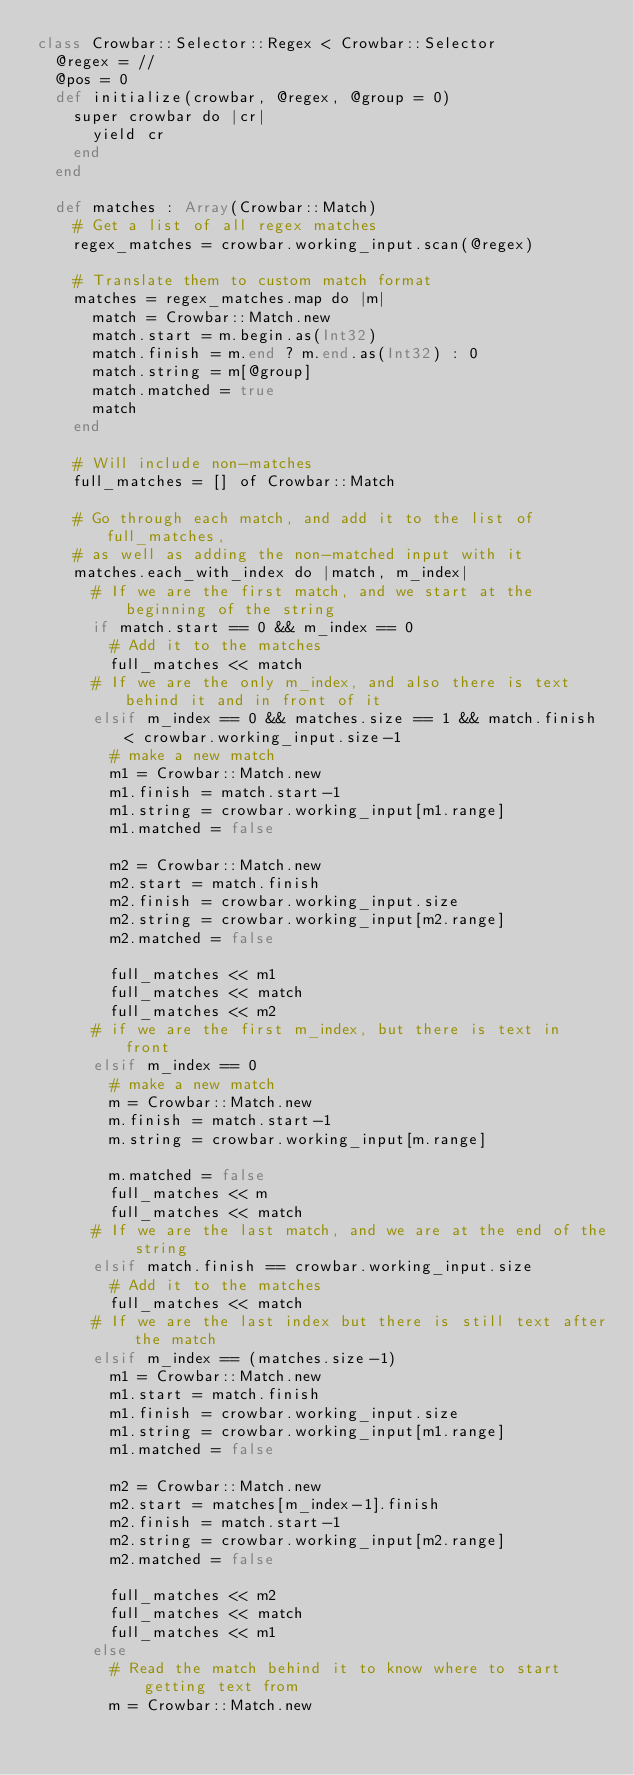<code> <loc_0><loc_0><loc_500><loc_500><_Crystal_>class Crowbar::Selector::Regex < Crowbar::Selector
  @regex = //
  @pos = 0
  def initialize(crowbar, @regex, @group = 0)
    super crowbar do |cr|
      yield cr
    end
  end

  def matches : Array(Crowbar::Match)
    # Get a list of all regex matches
    regex_matches = crowbar.working_input.scan(@regex)

    # Translate them to custom match format
    matches = regex_matches.map do |m|
      match = Crowbar::Match.new
      match.start = m.begin.as(Int32)
      match.finish = m.end ? m.end.as(Int32) : 0
      match.string = m[@group]
      match.matched = true
      match
    end

    # Will include non-matches
    full_matches = [] of Crowbar::Match

    # Go through each match, and add it to the list of full_matches,
    # as well as adding the non-matched input with it
    matches.each_with_index do |match, m_index|
      # If we are the first match, and we start at the beginning of the string
      if match.start == 0 && m_index == 0
        # Add it to the matches
        full_matches << match
      # If we are the only m_index, and also there is text behind it and in front of it
      elsif m_index == 0 && matches.size == 1 && match.finish < crowbar.working_input.size-1
        # make a new match
        m1 = Crowbar::Match.new
        m1.finish = match.start-1
        m1.string = crowbar.working_input[m1.range]
        m1.matched = false

        m2 = Crowbar::Match.new
        m2.start = match.finish
        m2.finish = crowbar.working_input.size
        m2.string = crowbar.working_input[m2.range]
        m2.matched = false

        full_matches << m1
        full_matches << match
        full_matches << m2
      # if we are the first m_index, but there is text in front
      elsif m_index == 0
        # make a new match
        m = Crowbar::Match.new
        m.finish = match.start-1
        m.string = crowbar.working_input[m.range]

        m.matched = false
        full_matches << m
        full_matches << match
      # If we are the last match, and we are at the end of the string
      elsif match.finish == crowbar.working_input.size
        # Add it to the matches
        full_matches << match
      # If we are the last index but there is still text after the match
      elsif m_index == (matches.size-1)
        m1 = Crowbar::Match.new
        m1.start = match.finish
        m1.finish = crowbar.working_input.size
        m1.string = crowbar.working_input[m1.range]
        m1.matched = false

        m2 = Crowbar::Match.new
        m2.start = matches[m_index-1].finish
        m2.finish = match.start-1
        m2.string = crowbar.working_input[m2.range]
        m2.matched = false

        full_matches << m2
        full_matches << match
        full_matches << m1
      else
        # Read the match behind it to know where to start getting text from
        m = Crowbar::Match.new</code> 